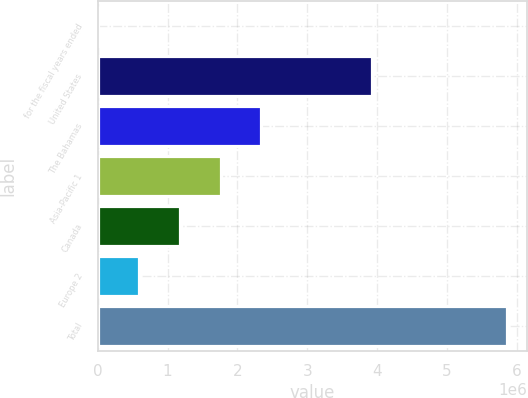<chart> <loc_0><loc_0><loc_500><loc_500><bar_chart><fcel>for the fiscal years ended<fcel>United States<fcel>The Bahamas<fcel>Asia-Pacific 1<fcel>Canada<fcel>Europe 2<fcel>Total<nl><fcel>2010<fcel>3.91995e+06<fcel>2.34241e+06<fcel>1.75731e+06<fcel>1.17221e+06<fcel>587109<fcel>5.853e+06<nl></chart> 